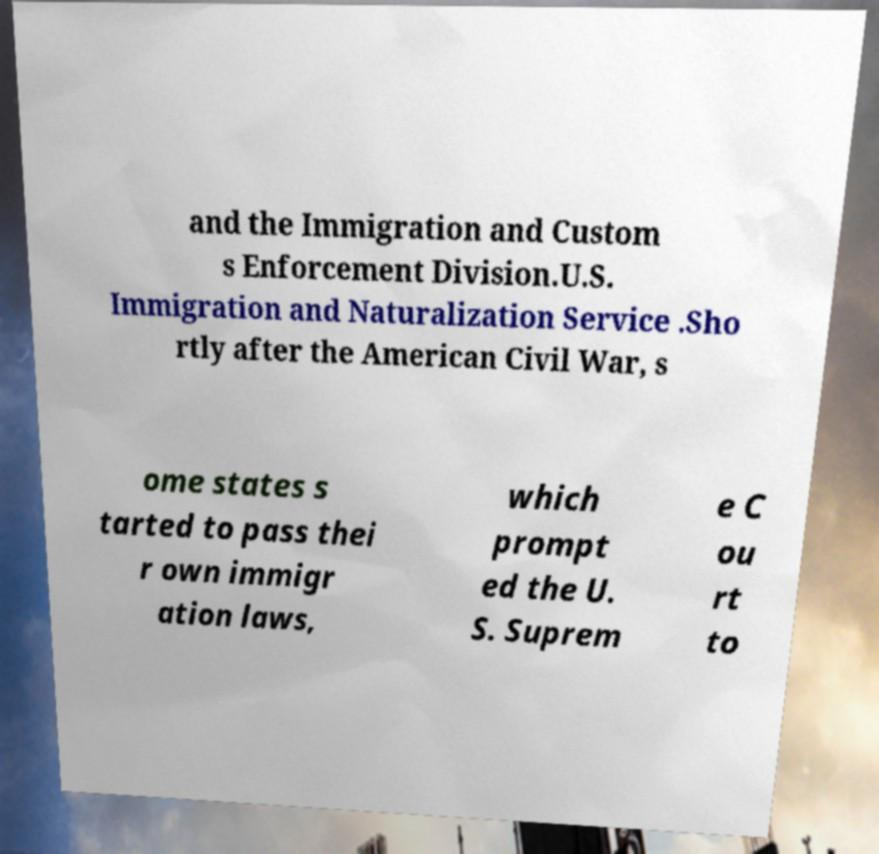I need the written content from this picture converted into text. Can you do that? and the Immigration and Custom s Enforcement Division.U.S. Immigration and Naturalization Service .Sho rtly after the American Civil War, s ome states s tarted to pass thei r own immigr ation laws, which prompt ed the U. S. Suprem e C ou rt to 